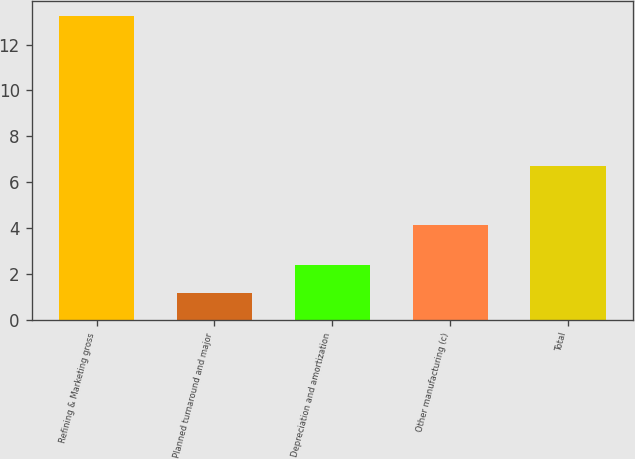Convert chart to OTSL. <chart><loc_0><loc_0><loc_500><loc_500><bar_chart><fcel>Refining & Marketing gross<fcel>Planned turnaround and major<fcel>Depreciation and amortization<fcel>Other manufacturing (c)<fcel>Total<nl><fcel>13.24<fcel>1.2<fcel>2.4<fcel>4.14<fcel>6.7<nl></chart> 